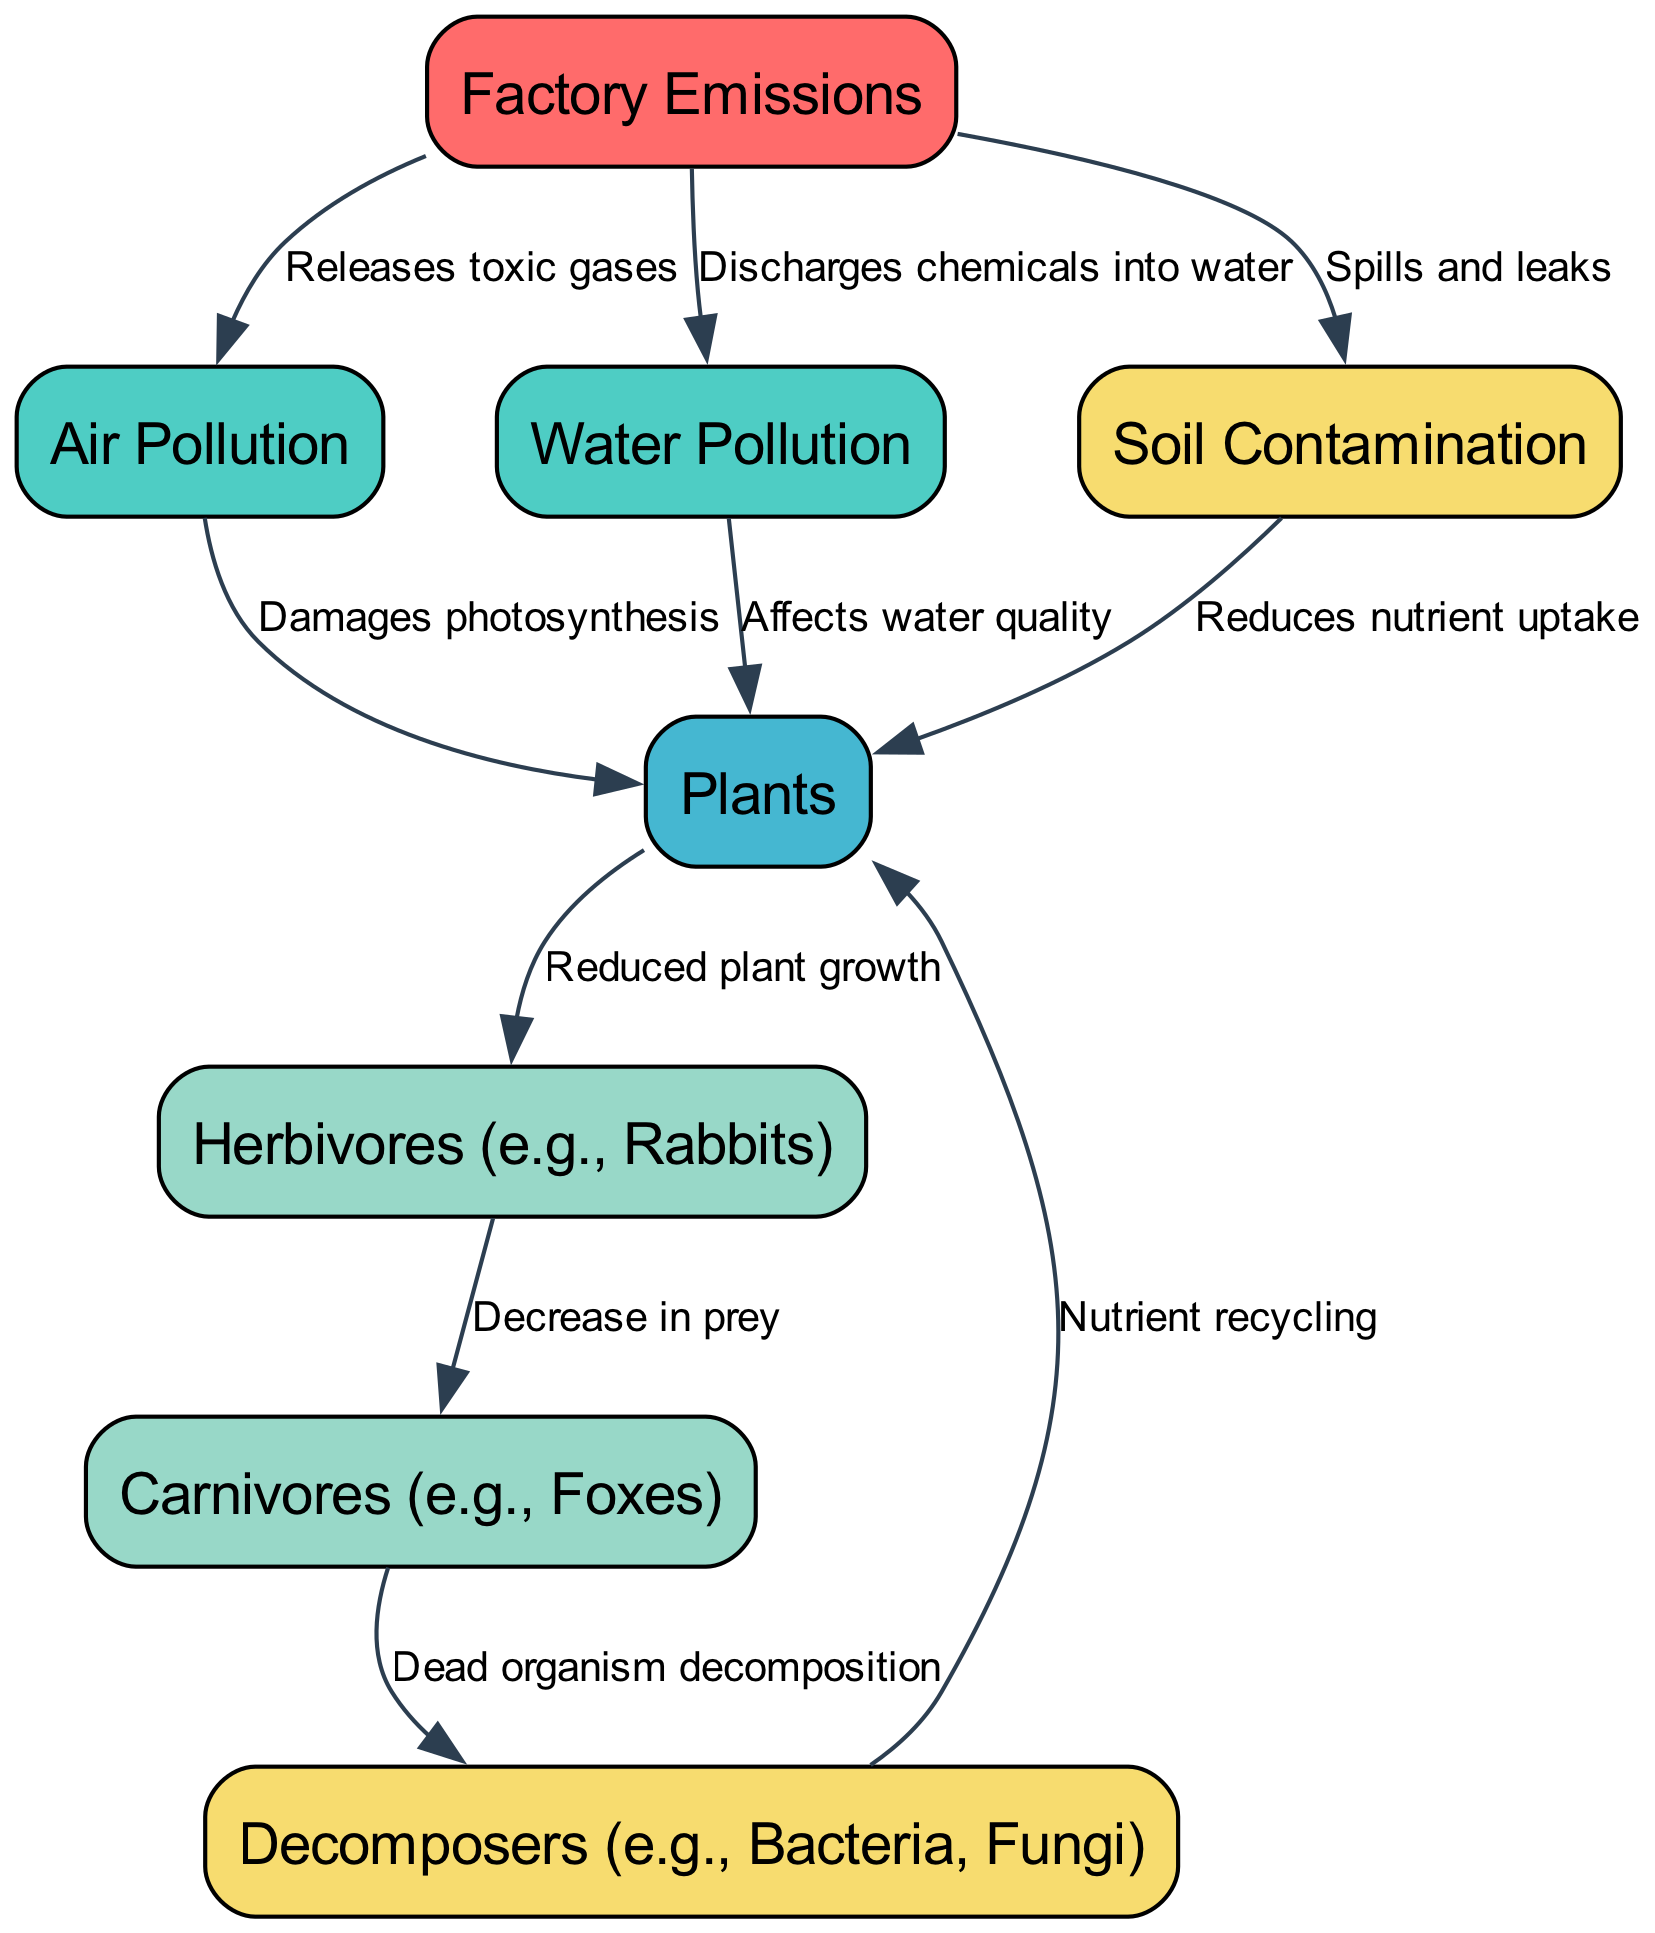What is the total number of nodes in the diagram? The diagram includes several distinct entities represented as nodes. By counting each individual node listed, we find that there are a total of eight nodes.
Answer: 8 Which node directly connects to "Factory Emissions"? The edges originating from "Factory Emissions" indicate that it connects directly to three other nodes: "Air Pollution," "Water Pollution," and "Soil Contamination." Each connection is marked with an arrow, indicating a direct relationship.
Answer: Air Pollution, Water Pollution, Soil Contamination What effect does "Air Pollution" have on "Plants"? According to the directed edge from "Air Pollution" to "Plants," the effect is that air pollution damages photosynthesis, which is critical for plant health and growth. This relationship explains how one node influences the other.
Answer: Damages photosynthesis How many types of consumers are in the diagram? The diagram contains two specific consumer nodes: "Herbivores" and "Carnivores." These are situated in a sequential flow after the "Plants" node, which indicates their reliance on plant life for sustenance.
Answer: 2 What happens to "Carnivores" when there is a decrease in "Herbivores"? The flow shows that a decrease in "Herbivores," which occurs due to reduced plant growth, directly impacts "Carnivores." Consequently, the connection indicates a reduction in their prey availability, leading to potential population impacts for carnivores.
Answer: Decrease in prey What role do "Decomposers" play in relation to "Carnivores"? The diagram illustrates that "Decomposers" are connected to "Carnivores" through the process of decomposition. Once carnivores die, their remains are processed by decomposers, indicating a crucial step in nutrient cycling within the ecosystem.
Answer: Dead organism decomposition Which type of pollution affects water quality as shown in the diagram? The relationship specified in the diagram indicates that "Water Pollution" explicitly affects "Plants," as it lowers the quality of the water they depend on. This clear connection highlights water pollution's direct impact.
Answer: Water Pollution What is the ultimate outcome of nutrient recycling by "Decomposers"? The diagram links "Decomposers" back to "Plants," illustrating that after they process dead organisms, they recycle nutrients back into the soil, which ultimately benefits plant growth and health. This completes the cycle of nutrient reuse in the ecosystem.
Answer: Nutrient recycling 